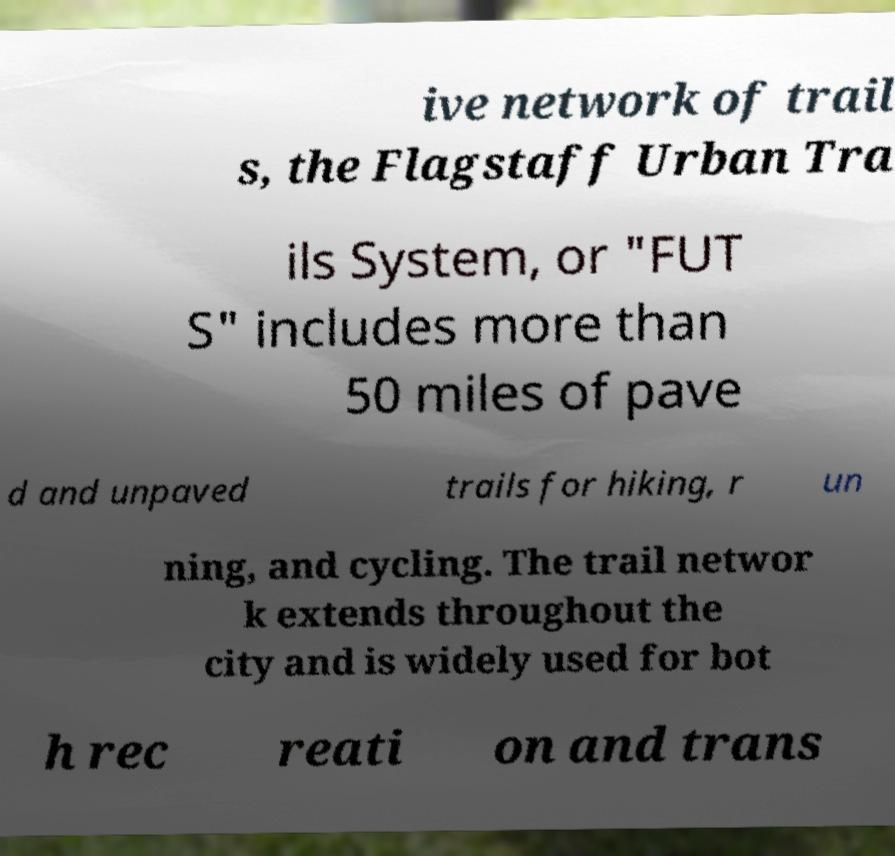Could you extract and type out the text from this image? ive network of trail s, the Flagstaff Urban Tra ils System, or "FUT S" includes more than 50 miles of pave d and unpaved trails for hiking, r un ning, and cycling. The trail networ k extends throughout the city and is widely used for bot h rec reati on and trans 